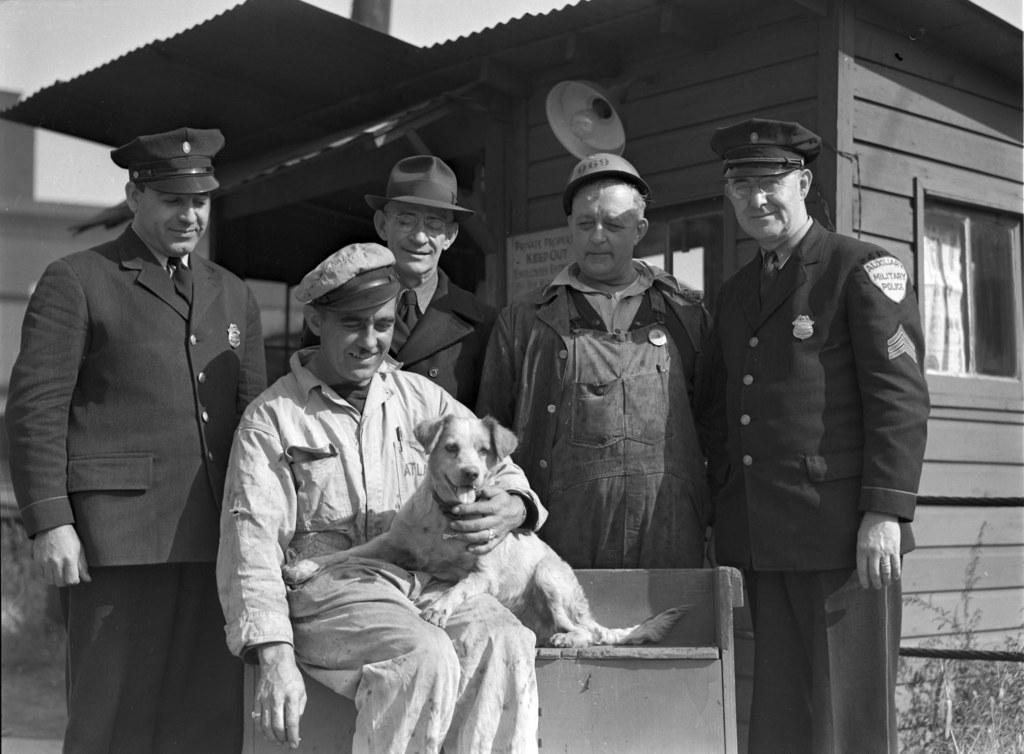What is the color scheme of the image? The image is black and white. What can be seen in terms of people in the image? There are persons standing in the image, and a man is sitting on a bench. What are the persons wearing in the image? The persons are wearing hats. Can you describe the man sitting on the bench? The man is holding a dog. What type of structure is present in the image? There is a house in the image. What features can be observed on the house? The house has a bulb and a window. Can you tell me how many pieces of lace are used to decorate the house in the image? There is no mention of lace in the image, so it cannot be determined how many pieces are used to decorate the house. 